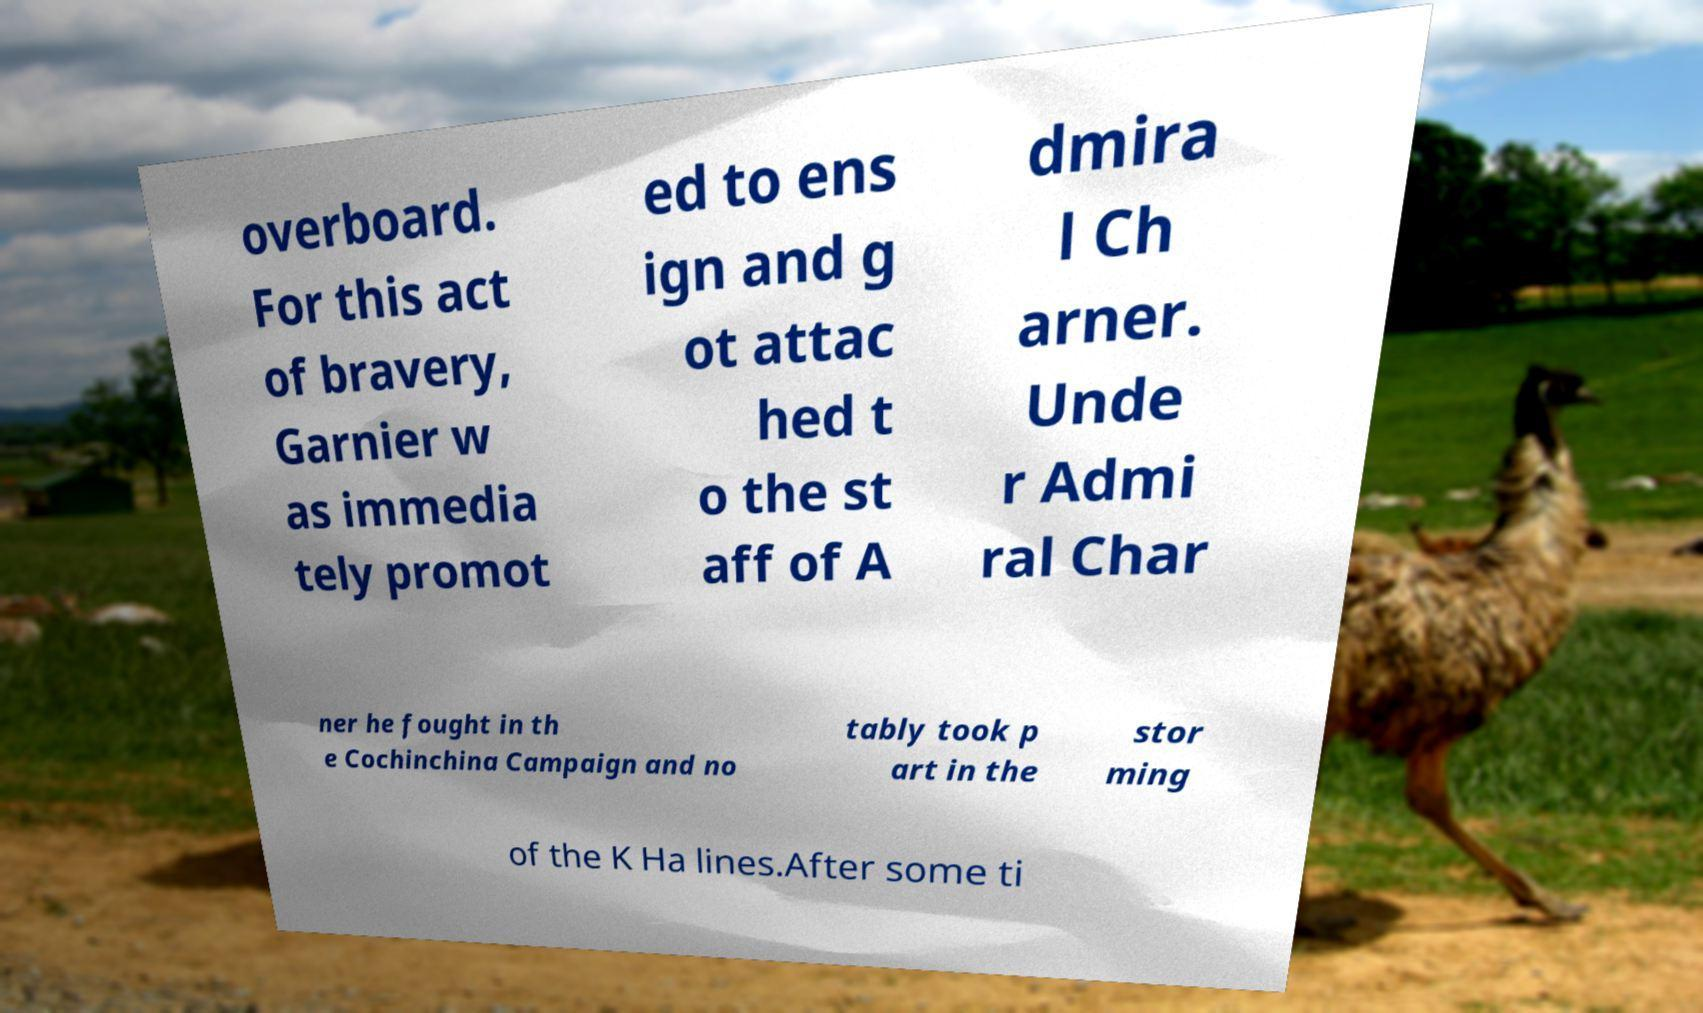For documentation purposes, I need the text within this image transcribed. Could you provide that? overboard. For this act of bravery, Garnier w as immedia tely promot ed to ens ign and g ot attac hed t o the st aff of A dmira l Ch arner. Unde r Admi ral Char ner he fought in th e Cochinchina Campaign and no tably took p art in the stor ming of the K Ha lines.After some ti 